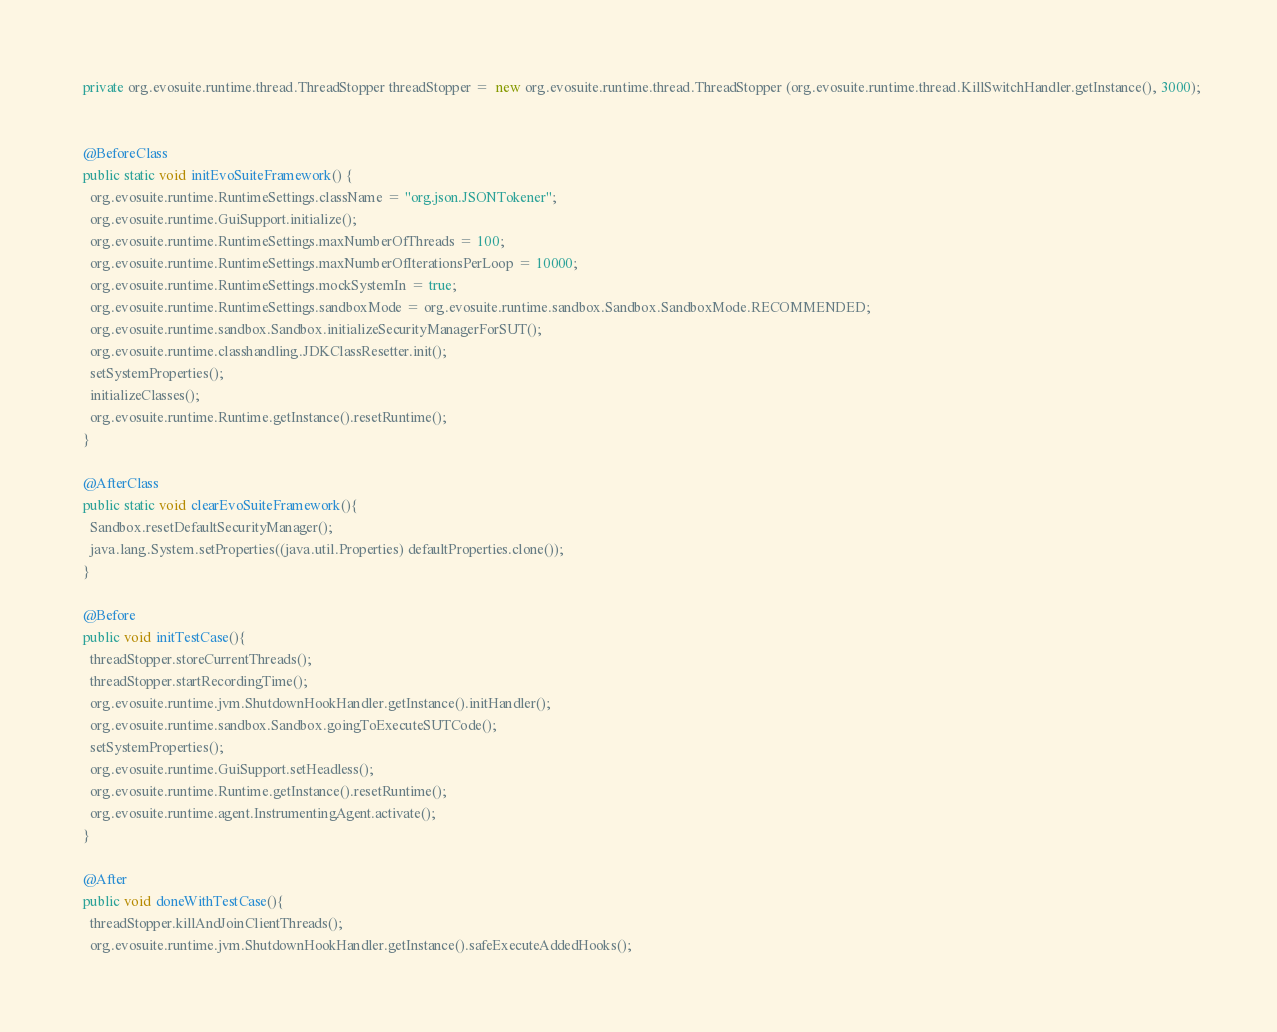Convert code to text. <code><loc_0><loc_0><loc_500><loc_500><_Java_>  private org.evosuite.runtime.thread.ThreadStopper threadStopper =  new org.evosuite.runtime.thread.ThreadStopper (org.evosuite.runtime.thread.KillSwitchHandler.getInstance(), 3000);


  @BeforeClass 
  public static void initEvoSuiteFramework() { 
    org.evosuite.runtime.RuntimeSettings.className = "org.json.JSONTokener"; 
    org.evosuite.runtime.GuiSupport.initialize(); 
    org.evosuite.runtime.RuntimeSettings.maxNumberOfThreads = 100; 
    org.evosuite.runtime.RuntimeSettings.maxNumberOfIterationsPerLoop = 10000; 
    org.evosuite.runtime.RuntimeSettings.mockSystemIn = true; 
    org.evosuite.runtime.RuntimeSettings.sandboxMode = org.evosuite.runtime.sandbox.Sandbox.SandboxMode.RECOMMENDED; 
    org.evosuite.runtime.sandbox.Sandbox.initializeSecurityManagerForSUT(); 
    org.evosuite.runtime.classhandling.JDKClassResetter.init();
    setSystemProperties();
    initializeClasses();
    org.evosuite.runtime.Runtime.getInstance().resetRuntime(); 
  } 

  @AfterClass 
  public static void clearEvoSuiteFramework(){ 
    Sandbox.resetDefaultSecurityManager(); 
    java.lang.System.setProperties((java.util.Properties) defaultProperties.clone()); 
  } 

  @Before 
  public void initTestCase(){ 
    threadStopper.storeCurrentThreads();
    threadStopper.startRecordingTime();
    org.evosuite.runtime.jvm.ShutdownHookHandler.getInstance().initHandler(); 
    org.evosuite.runtime.sandbox.Sandbox.goingToExecuteSUTCode(); 
    setSystemProperties(); 
    org.evosuite.runtime.GuiSupport.setHeadless(); 
    org.evosuite.runtime.Runtime.getInstance().resetRuntime(); 
    org.evosuite.runtime.agent.InstrumentingAgent.activate(); 
  } 

  @After 
  public void doneWithTestCase(){ 
    threadStopper.killAndJoinClientThreads();
    org.evosuite.runtime.jvm.ShutdownHookHandler.getInstance().safeExecuteAddedHooks(); </code> 